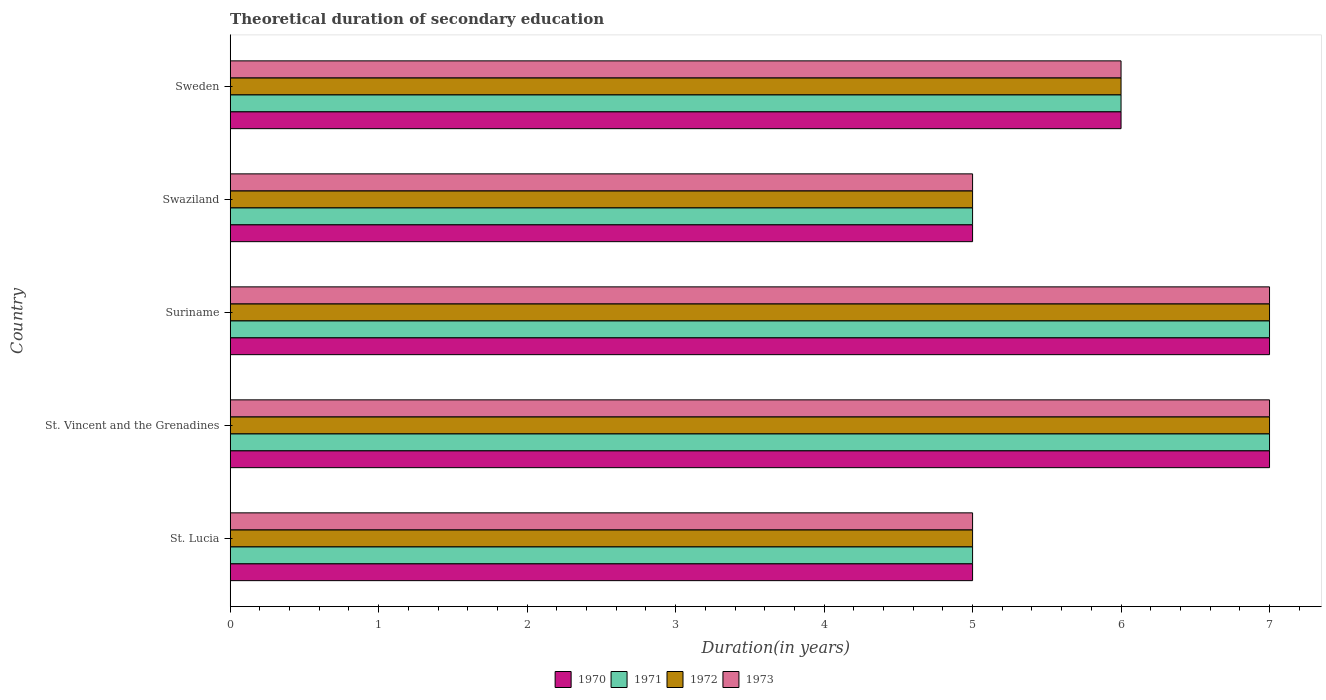How many groups of bars are there?
Your response must be concise. 5. Are the number of bars per tick equal to the number of legend labels?
Give a very brief answer. Yes. Are the number of bars on each tick of the Y-axis equal?
Offer a terse response. Yes. What is the label of the 2nd group of bars from the top?
Ensure brevity in your answer.  Swaziland. In how many cases, is the number of bars for a given country not equal to the number of legend labels?
Your answer should be very brief. 0. What is the total theoretical duration of secondary education in 1973 in St. Lucia?
Your answer should be compact. 5. In which country was the total theoretical duration of secondary education in 1970 maximum?
Your response must be concise. St. Vincent and the Grenadines. In which country was the total theoretical duration of secondary education in 1972 minimum?
Your response must be concise. St. Lucia. What is the total total theoretical duration of secondary education in 1972 in the graph?
Ensure brevity in your answer.  30. What is the difference between the total theoretical duration of secondary education in 1970 in St. Lucia and the total theoretical duration of secondary education in 1972 in Swaziland?
Give a very brief answer. 0. What is the ratio of the total theoretical duration of secondary education in 1970 in St. Vincent and the Grenadines to that in Swaziland?
Offer a very short reply. 1.4. Is the difference between the total theoretical duration of secondary education in 1970 in St. Lucia and Swaziland greater than the difference between the total theoretical duration of secondary education in 1973 in St. Lucia and Swaziland?
Your answer should be very brief. No. What is the difference between the highest and the second highest total theoretical duration of secondary education in 1973?
Your answer should be compact. 0. Is the sum of the total theoretical duration of secondary education in 1973 in St. Lucia and Suriname greater than the maximum total theoretical duration of secondary education in 1972 across all countries?
Your response must be concise. Yes. What does the 3rd bar from the top in Suriname represents?
Provide a succinct answer. 1971. What does the 2nd bar from the bottom in St. Vincent and the Grenadines represents?
Your response must be concise. 1971. Is it the case that in every country, the sum of the total theoretical duration of secondary education in 1973 and total theoretical duration of secondary education in 1971 is greater than the total theoretical duration of secondary education in 1972?
Offer a terse response. Yes. Are all the bars in the graph horizontal?
Offer a terse response. Yes. Are the values on the major ticks of X-axis written in scientific E-notation?
Your response must be concise. No. Does the graph contain any zero values?
Keep it short and to the point. No. Does the graph contain grids?
Provide a short and direct response. No. Where does the legend appear in the graph?
Give a very brief answer. Bottom center. What is the title of the graph?
Offer a very short reply. Theoretical duration of secondary education. What is the label or title of the X-axis?
Offer a very short reply. Duration(in years). What is the label or title of the Y-axis?
Ensure brevity in your answer.  Country. What is the Duration(in years) in 1970 in St. Lucia?
Make the answer very short. 5. What is the Duration(in years) in 1971 in St. Lucia?
Offer a terse response. 5. What is the Duration(in years) in 1973 in St. Lucia?
Ensure brevity in your answer.  5. What is the Duration(in years) in 1972 in St. Vincent and the Grenadines?
Offer a very short reply. 7. What is the Duration(in years) of 1970 in Suriname?
Give a very brief answer. 7. What is the Duration(in years) in 1971 in Suriname?
Offer a terse response. 7. What is the Duration(in years) of 1970 in Sweden?
Keep it short and to the point. 6. What is the Duration(in years) in 1971 in Sweden?
Your response must be concise. 6. What is the Duration(in years) of 1973 in Sweden?
Offer a very short reply. 6. Across all countries, what is the minimum Duration(in years) of 1970?
Provide a succinct answer. 5. What is the total Duration(in years) of 1971 in the graph?
Make the answer very short. 30. What is the total Duration(in years) in 1972 in the graph?
Your answer should be very brief. 30. What is the difference between the Duration(in years) in 1970 in St. Lucia and that in St. Vincent and the Grenadines?
Your response must be concise. -2. What is the difference between the Duration(in years) in 1971 in St. Lucia and that in St. Vincent and the Grenadines?
Ensure brevity in your answer.  -2. What is the difference between the Duration(in years) of 1970 in St. Lucia and that in Suriname?
Ensure brevity in your answer.  -2. What is the difference between the Duration(in years) in 1972 in St. Lucia and that in Suriname?
Ensure brevity in your answer.  -2. What is the difference between the Duration(in years) in 1970 in St. Lucia and that in Swaziland?
Offer a very short reply. 0. What is the difference between the Duration(in years) of 1970 in St. Lucia and that in Sweden?
Provide a short and direct response. -1. What is the difference between the Duration(in years) in 1971 in St. Lucia and that in Sweden?
Your response must be concise. -1. What is the difference between the Duration(in years) in 1972 in St. Lucia and that in Sweden?
Offer a terse response. -1. What is the difference between the Duration(in years) of 1971 in St. Vincent and the Grenadines and that in Suriname?
Provide a short and direct response. 0. What is the difference between the Duration(in years) in 1972 in St. Vincent and the Grenadines and that in Suriname?
Your answer should be compact. 0. What is the difference between the Duration(in years) in 1970 in St. Vincent and the Grenadines and that in Swaziland?
Your answer should be compact. 2. What is the difference between the Duration(in years) in 1971 in St. Vincent and the Grenadines and that in Sweden?
Your answer should be compact. 1. What is the difference between the Duration(in years) of 1972 in St. Vincent and the Grenadines and that in Sweden?
Ensure brevity in your answer.  1. What is the difference between the Duration(in years) in 1971 in Suriname and that in Swaziland?
Offer a terse response. 2. What is the difference between the Duration(in years) in 1972 in Suriname and that in Swaziland?
Give a very brief answer. 2. What is the difference between the Duration(in years) in 1971 in Suriname and that in Sweden?
Give a very brief answer. 1. What is the difference between the Duration(in years) in 1971 in Swaziland and that in Sweden?
Your answer should be very brief. -1. What is the difference between the Duration(in years) of 1972 in Swaziland and that in Sweden?
Ensure brevity in your answer.  -1. What is the difference between the Duration(in years) in 1973 in Swaziland and that in Sweden?
Make the answer very short. -1. What is the difference between the Duration(in years) in 1970 in St. Lucia and the Duration(in years) in 1972 in St. Vincent and the Grenadines?
Provide a short and direct response. -2. What is the difference between the Duration(in years) of 1970 in St. Lucia and the Duration(in years) of 1973 in St. Vincent and the Grenadines?
Keep it short and to the point. -2. What is the difference between the Duration(in years) in 1971 in St. Lucia and the Duration(in years) in 1973 in St. Vincent and the Grenadines?
Offer a terse response. -2. What is the difference between the Duration(in years) in 1970 in St. Lucia and the Duration(in years) in 1972 in Suriname?
Give a very brief answer. -2. What is the difference between the Duration(in years) in 1970 in St. Lucia and the Duration(in years) in 1971 in Swaziland?
Your response must be concise. 0. What is the difference between the Duration(in years) of 1971 in St. Lucia and the Duration(in years) of 1973 in Swaziland?
Offer a terse response. 0. What is the difference between the Duration(in years) in 1970 in St. Lucia and the Duration(in years) in 1972 in Sweden?
Your response must be concise. -1. What is the difference between the Duration(in years) of 1971 in St. Lucia and the Duration(in years) of 1972 in Sweden?
Your answer should be very brief. -1. What is the difference between the Duration(in years) of 1970 in St. Vincent and the Grenadines and the Duration(in years) of 1972 in Suriname?
Your answer should be very brief. 0. What is the difference between the Duration(in years) of 1970 in St. Vincent and the Grenadines and the Duration(in years) of 1973 in Suriname?
Your answer should be compact. 0. What is the difference between the Duration(in years) in 1971 in St. Vincent and the Grenadines and the Duration(in years) in 1972 in Suriname?
Offer a terse response. 0. What is the difference between the Duration(in years) of 1972 in St. Vincent and the Grenadines and the Duration(in years) of 1973 in Suriname?
Provide a short and direct response. 0. What is the difference between the Duration(in years) of 1970 in St. Vincent and the Grenadines and the Duration(in years) of 1971 in Swaziland?
Your answer should be very brief. 2. What is the difference between the Duration(in years) in 1970 in St. Vincent and the Grenadines and the Duration(in years) in 1972 in Swaziland?
Offer a very short reply. 2. What is the difference between the Duration(in years) of 1970 in St. Vincent and the Grenadines and the Duration(in years) of 1973 in Swaziland?
Keep it short and to the point. 2. What is the difference between the Duration(in years) in 1972 in St. Vincent and the Grenadines and the Duration(in years) in 1973 in Swaziland?
Your answer should be very brief. 2. What is the difference between the Duration(in years) in 1970 in St. Vincent and the Grenadines and the Duration(in years) in 1971 in Sweden?
Your answer should be compact. 1. What is the difference between the Duration(in years) of 1971 in St. Vincent and the Grenadines and the Duration(in years) of 1972 in Sweden?
Offer a terse response. 1. What is the difference between the Duration(in years) in 1971 in St. Vincent and the Grenadines and the Duration(in years) in 1973 in Sweden?
Provide a short and direct response. 1. What is the difference between the Duration(in years) of 1972 in St. Vincent and the Grenadines and the Duration(in years) of 1973 in Sweden?
Your answer should be very brief. 1. What is the difference between the Duration(in years) in 1970 in Suriname and the Duration(in years) in 1971 in Swaziland?
Provide a short and direct response. 2. What is the difference between the Duration(in years) of 1971 in Suriname and the Duration(in years) of 1972 in Swaziland?
Ensure brevity in your answer.  2. What is the difference between the Duration(in years) in 1971 in Suriname and the Duration(in years) in 1973 in Swaziland?
Your response must be concise. 2. What is the difference between the Duration(in years) of 1970 in Suriname and the Duration(in years) of 1971 in Sweden?
Give a very brief answer. 1. What is the difference between the Duration(in years) of 1970 in Suriname and the Duration(in years) of 1972 in Sweden?
Give a very brief answer. 1. What is the difference between the Duration(in years) in 1970 in Suriname and the Duration(in years) in 1973 in Sweden?
Make the answer very short. 1. What is the difference between the Duration(in years) in 1971 in Suriname and the Duration(in years) in 1972 in Sweden?
Keep it short and to the point. 1. What is the difference between the Duration(in years) of 1971 in Suriname and the Duration(in years) of 1973 in Sweden?
Your answer should be very brief. 1. What is the difference between the Duration(in years) of 1970 in Swaziland and the Duration(in years) of 1971 in Sweden?
Give a very brief answer. -1. What is the difference between the Duration(in years) in 1970 in Swaziland and the Duration(in years) in 1972 in Sweden?
Keep it short and to the point. -1. What is the difference between the Duration(in years) in 1970 in Swaziland and the Duration(in years) in 1973 in Sweden?
Your answer should be very brief. -1. What is the difference between the Duration(in years) of 1971 in Swaziland and the Duration(in years) of 1972 in Sweden?
Provide a succinct answer. -1. What is the difference between the Duration(in years) in 1971 in Swaziland and the Duration(in years) in 1973 in Sweden?
Your response must be concise. -1. What is the average Duration(in years) in 1971 per country?
Offer a terse response. 6. What is the average Duration(in years) of 1972 per country?
Offer a very short reply. 6. What is the average Duration(in years) of 1973 per country?
Make the answer very short. 6. What is the difference between the Duration(in years) of 1970 and Duration(in years) of 1971 in St. Lucia?
Offer a terse response. 0. What is the difference between the Duration(in years) in 1971 and Duration(in years) in 1972 in St. Lucia?
Ensure brevity in your answer.  0. What is the difference between the Duration(in years) of 1971 and Duration(in years) of 1973 in St. Lucia?
Your response must be concise. 0. What is the difference between the Duration(in years) of 1972 and Duration(in years) of 1973 in St. Lucia?
Offer a terse response. 0. What is the difference between the Duration(in years) of 1970 and Duration(in years) of 1973 in St. Vincent and the Grenadines?
Make the answer very short. 0. What is the difference between the Duration(in years) of 1971 and Duration(in years) of 1973 in St. Vincent and the Grenadines?
Provide a short and direct response. 0. What is the difference between the Duration(in years) of 1970 and Duration(in years) of 1973 in Suriname?
Your answer should be compact. 0. What is the difference between the Duration(in years) of 1971 and Duration(in years) of 1972 in Suriname?
Offer a very short reply. 0. What is the difference between the Duration(in years) in 1971 and Duration(in years) in 1973 in Suriname?
Your answer should be compact. 0. What is the difference between the Duration(in years) of 1972 and Duration(in years) of 1973 in Suriname?
Give a very brief answer. 0. What is the difference between the Duration(in years) of 1970 and Duration(in years) of 1972 in Swaziland?
Offer a terse response. 0. What is the difference between the Duration(in years) of 1971 and Duration(in years) of 1973 in Swaziland?
Keep it short and to the point. 0. What is the difference between the Duration(in years) of 1970 and Duration(in years) of 1971 in Sweden?
Your response must be concise. 0. What is the difference between the Duration(in years) of 1970 and Duration(in years) of 1972 in Sweden?
Offer a terse response. 0. What is the difference between the Duration(in years) in 1970 and Duration(in years) in 1973 in Sweden?
Provide a short and direct response. 0. What is the difference between the Duration(in years) in 1971 and Duration(in years) in 1973 in Sweden?
Provide a succinct answer. 0. What is the difference between the Duration(in years) of 1972 and Duration(in years) of 1973 in Sweden?
Your response must be concise. 0. What is the ratio of the Duration(in years) of 1970 in St. Lucia to that in St. Vincent and the Grenadines?
Keep it short and to the point. 0.71. What is the ratio of the Duration(in years) of 1971 in St. Lucia to that in St. Vincent and the Grenadines?
Provide a succinct answer. 0.71. What is the ratio of the Duration(in years) of 1970 in St. Lucia to that in Suriname?
Provide a short and direct response. 0.71. What is the ratio of the Duration(in years) in 1970 in St. Lucia to that in Swaziland?
Provide a succinct answer. 1. What is the ratio of the Duration(in years) of 1971 in St. Lucia to that in Swaziland?
Offer a terse response. 1. What is the ratio of the Duration(in years) in 1971 in St. Lucia to that in Sweden?
Your response must be concise. 0.83. What is the ratio of the Duration(in years) of 1972 in St. Lucia to that in Sweden?
Provide a succinct answer. 0.83. What is the ratio of the Duration(in years) in 1972 in St. Vincent and the Grenadines to that in Suriname?
Your answer should be compact. 1. What is the ratio of the Duration(in years) in 1970 in St. Vincent and the Grenadines to that in Swaziland?
Provide a succinct answer. 1.4. What is the ratio of the Duration(in years) in 1973 in St. Vincent and the Grenadines to that in Swaziland?
Your answer should be very brief. 1.4. What is the ratio of the Duration(in years) of 1971 in St. Vincent and the Grenadines to that in Sweden?
Provide a succinct answer. 1.17. What is the ratio of the Duration(in years) in 1972 in St. Vincent and the Grenadines to that in Sweden?
Keep it short and to the point. 1.17. What is the ratio of the Duration(in years) of 1972 in Suriname to that in Swaziland?
Give a very brief answer. 1.4. What is the ratio of the Duration(in years) in 1973 in Suriname to that in Swaziland?
Your answer should be very brief. 1.4. What is the ratio of the Duration(in years) in 1970 in Suriname to that in Sweden?
Provide a succinct answer. 1.17. What is the ratio of the Duration(in years) in 1971 in Suriname to that in Sweden?
Your answer should be compact. 1.17. What is the difference between the highest and the second highest Duration(in years) in 1970?
Your response must be concise. 0. What is the difference between the highest and the second highest Duration(in years) in 1972?
Your answer should be compact. 0. What is the difference between the highest and the lowest Duration(in years) in 1970?
Your answer should be very brief. 2. What is the difference between the highest and the lowest Duration(in years) in 1971?
Offer a terse response. 2. What is the difference between the highest and the lowest Duration(in years) of 1972?
Your answer should be compact. 2. 